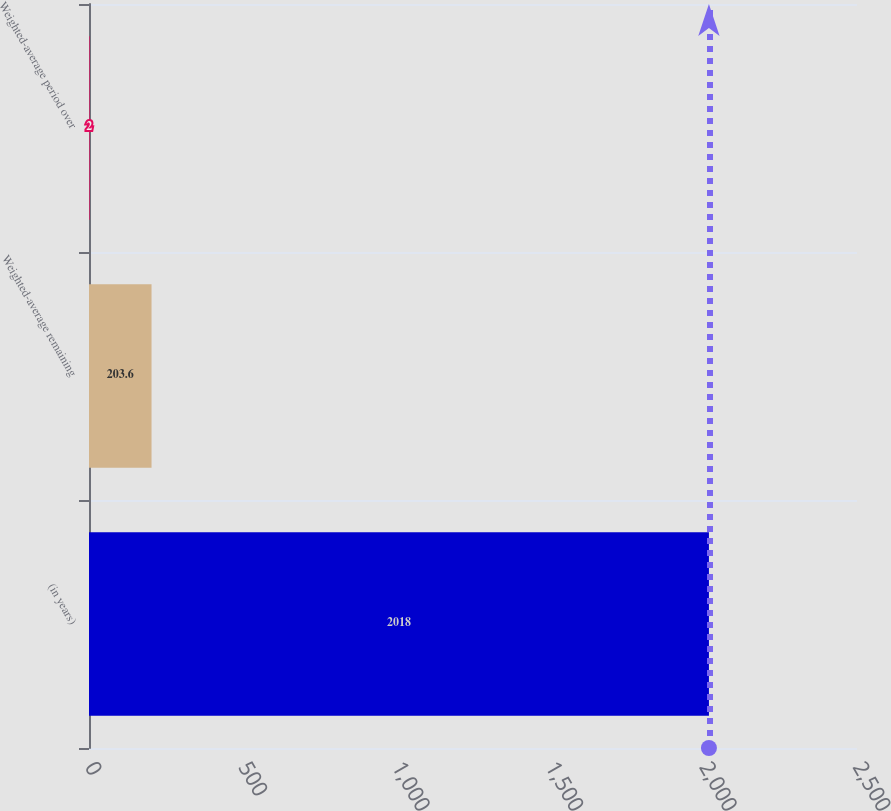Convert chart. <chart><loc_0><loc_0><loc_500><loc_500><bar_chart><fcel>(in years)<fcel>Weighted-average remaining<fcel>Weighted-average period over<nl><fcel>2018<fcel>203.6<fcel>2<nl></chart> 